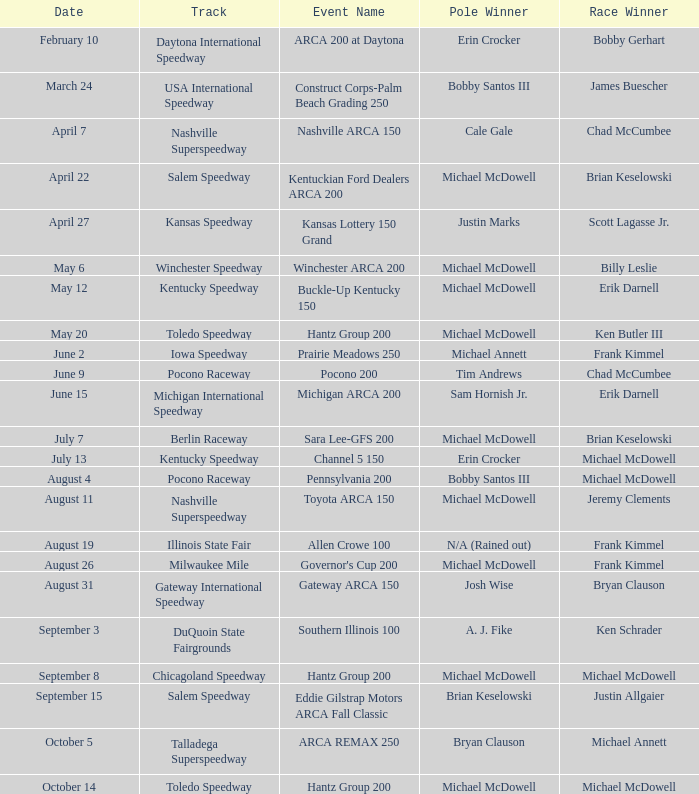Tell me the track for june 9 Pocono Raceway. 